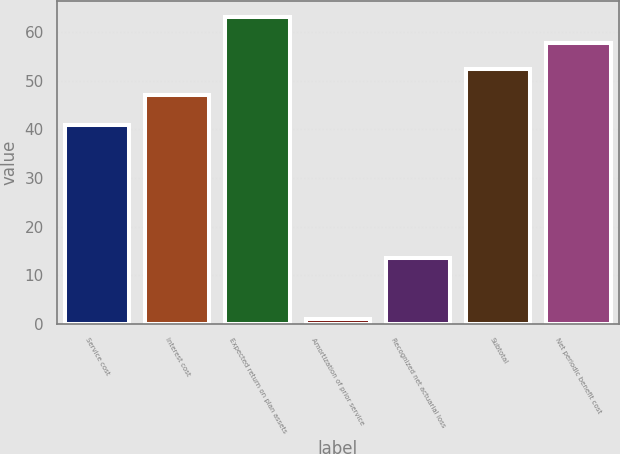Convert chart. <chart><loc_0><loc_0><loc_500><loc_500><bar_chart><fcel>Service cost<fcel>Interest cost<fcel>Expected return on plan assets<fcel>Amortization of prior service<fcel>Recognized net actuarial loss<fcel>Subtotal<fcel>Net periodic benefit cost<nl><fcel>40.9<fcel>47.1<fcel>63.18<fcel>0.9<fcel>13.5<fcel>52.46<fcel>57.82<nl></chart> 